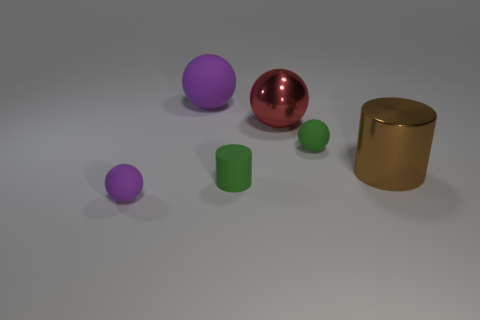What color is the small rubber ball that is in front of the matte cylinder on the left side of the large metal object to the right of the red sphere?
Your answer should be very brief. Purple. There is a thing that is the same material as the red sphere; what is its shape?
Provide a succinct answer. Cylinder. Are there fewer green balls than purple spheres?
Keep it short and to the point. Yes. Are the large purple sphere and the big cylinder made of the same material?
Offer a very short reply. No. How many other objects are there of the same color as the metallic sphere?
Make the answer very short. 0. Is the number of small green spheres greater than the number of small purple shiny things?
Make the answer very short. Yes. There is a red thing; is it the same size as the thing left of the large purple sphere?
Provide a short and direct response. No. What is the color of the cylinder in front of the big brown shiny cylinder?
Offer a very short reply. Green. How many blue things are either cubes or small spheres?
Your answer should be compact. 0. What is the color of the small cylinder?
Your answer should be compact. Green. 